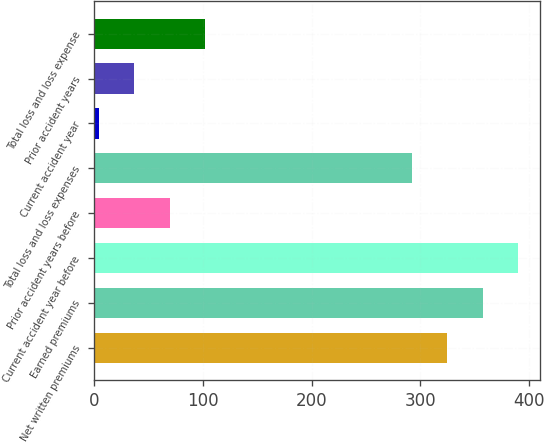Convert chart. <chart><loc_0><loc_0><loc_500><loc_500><bar_chart><fcel>Net written premiums<fcel>Earned premiums<fcel>Current accident year before<fcel>Prior accident years before<fcel>Total loss and loss expenses<fcel>Current accident year<fcel>Prior accident years<fcel>Total loss and loss expense<nl><fcel>324.66<fcel>357.32<fcel>389.98<fcel>69.72<fcel>292<fcel>4.4<fcel>37.06<fcel>102.38<nl></chart> 